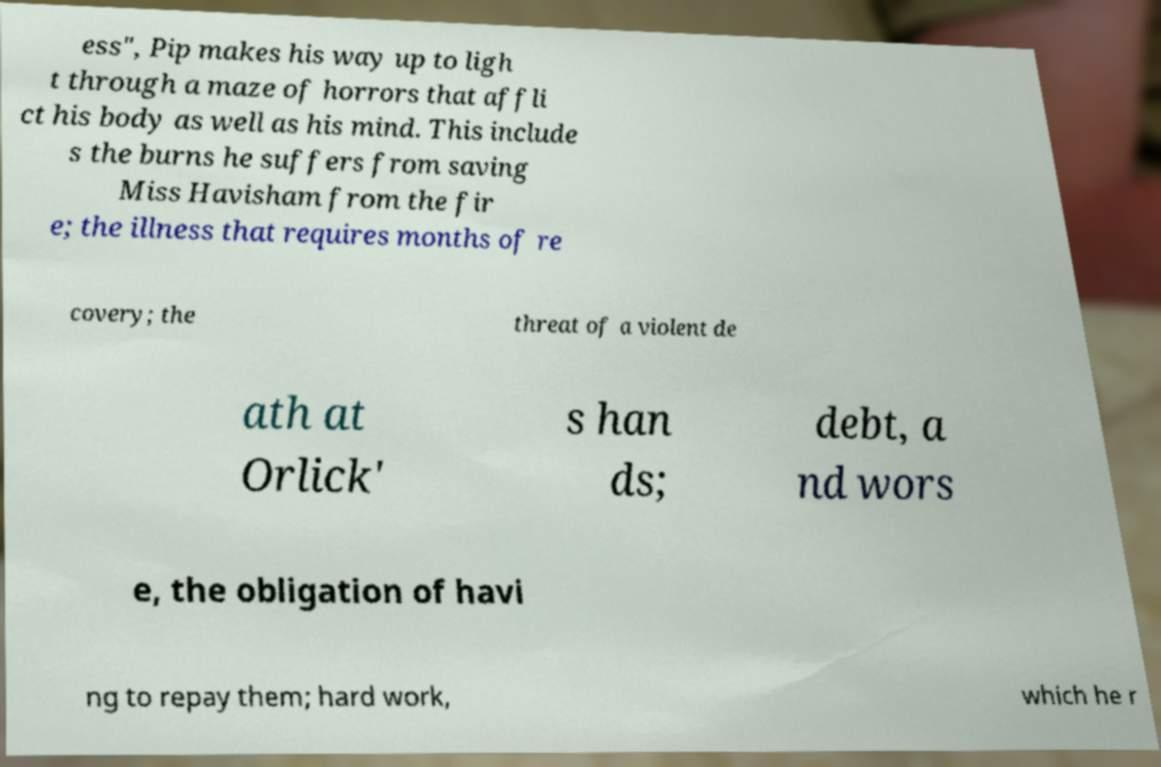Can you read and provide the text displayed in the image?This photo seems to have some interesting text. Can you extract and type it out for me? ess", Pip makes his way up to ligh t through a maze of horrors that affli ct his body as well as his mind. This include s the burns he suffers from saving Miss Havisham from the fir e; the illness that requires months of re covery; the threat of a violent de ath at Orlick' s han ds; debt, a nd wors e, the obligation of havi ng to repay them; hard work, which he r 